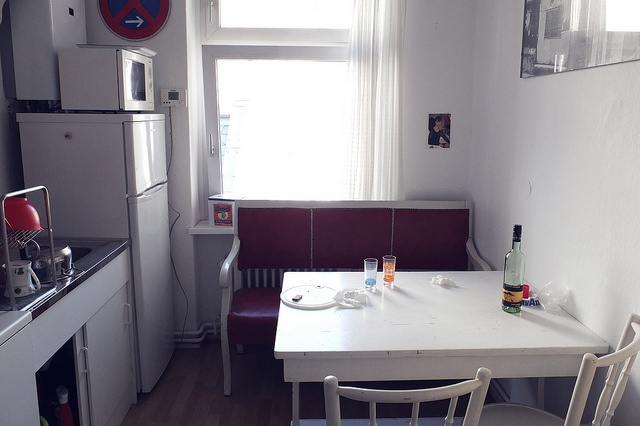Describe the objects in this image and their specific colors. I can see dining table in gray, lightgray, and darkgray tones, refrigerator in gray, darkgray, lightgray, and black tones, chair in gray, black, and purple tones, bench in gray, black, and purple tones, and microwave in gray, lightgray, black, and darkgray tones in this image. 